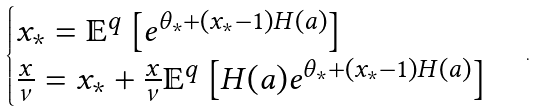<formula> <loc_0><loc_0><loc_500><loc_500>\begin{cases} x _ { \ast } = \mathbb { E } ^ { q } \left [ e ^ { \theta _ { \ast } + ( x _ { \ast } - 1 ) H ( a ) } \right ] \\ \frac { x } { \nu } = x _ { \ast } + \frac { x } { \nu } \mathbb { E } ^ { q } \left [ H ( a ) e ^ { \theta _ { \ast } + ( x _ { \ast } - 1 ) H ( a ) } \right ] \end{cases} .</formula> 